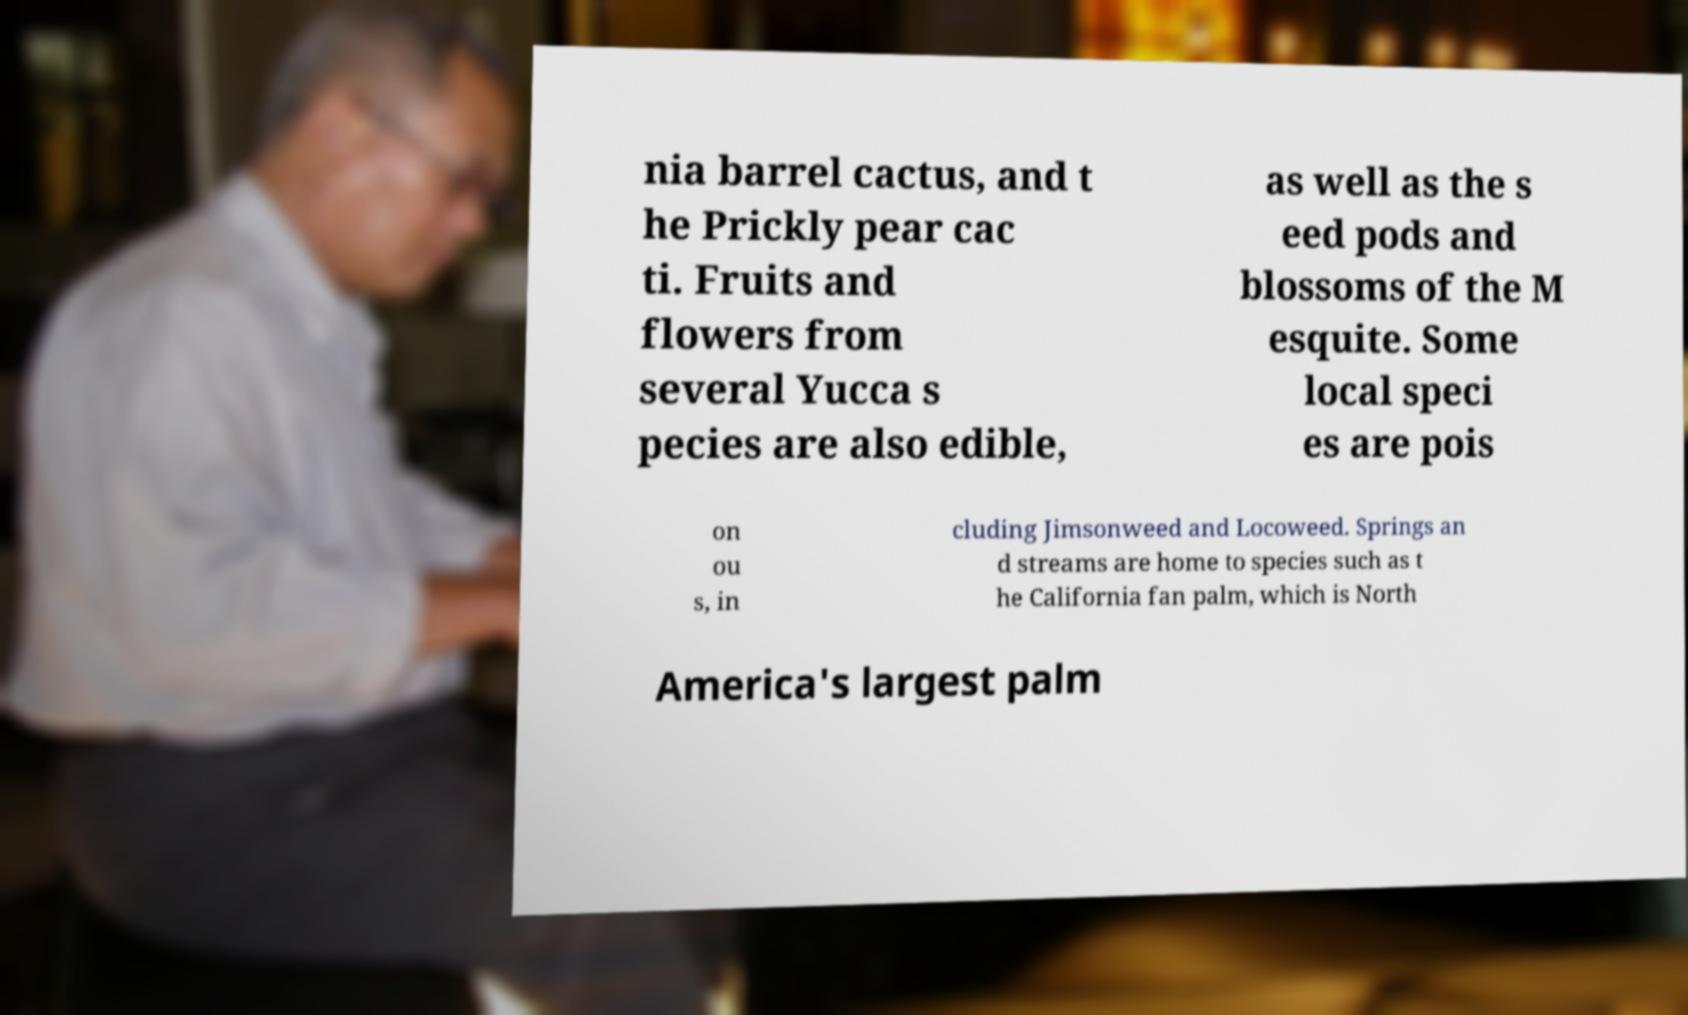Please identify and transcribe the text found in this image. nia barrel cactus, and t he Prickly pear cac ti. Fruits and flowers from several Yucca s pecies are also edible, as well as the s eed pods and blossoms of the M esquite. Some local speci es are pois on ou s, in cluding Jimsonweed and Locoweed. Springs an d streams are home to species such as t he California fan palm, which is North America's largest palm 